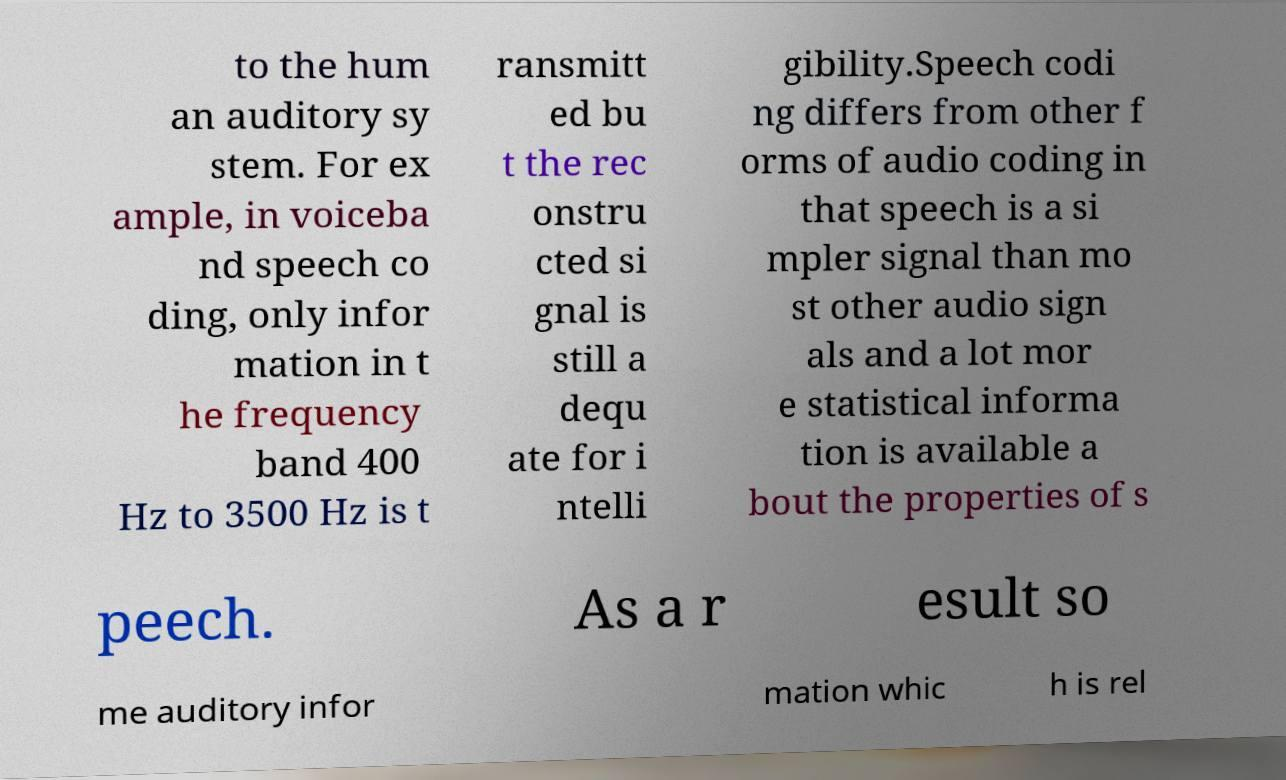There's text embedded in this image that I need extracted. Can you transcribe it verbatim? to the hum an auditory sy stem. For ex ample, in voiceba nd speech co ding, only infor mation in t he frequency band 400 Hz to 3500 Hz is t ransmitt ed bu t the rec onstru cted si gnal is still a dequ ate for i ntelli gibility.Speech codi ng differs from other f orms of audio coding in that speech is a si mpler signal than mo st other audio sign als and a lot mor e statistical informa tion is available a bout the properties of s peech. As a r esult so me auditory infor mation whic h is rel 